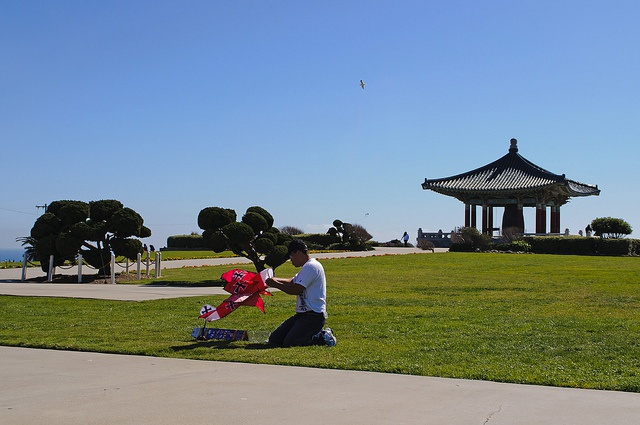Describe the objects in this image and their specific colors. I can see people in gray, black, blue, and lavender tones, kite in gray, maroon, black, and brown tones, and people in gray, black, blue, and navy tones in this image. 